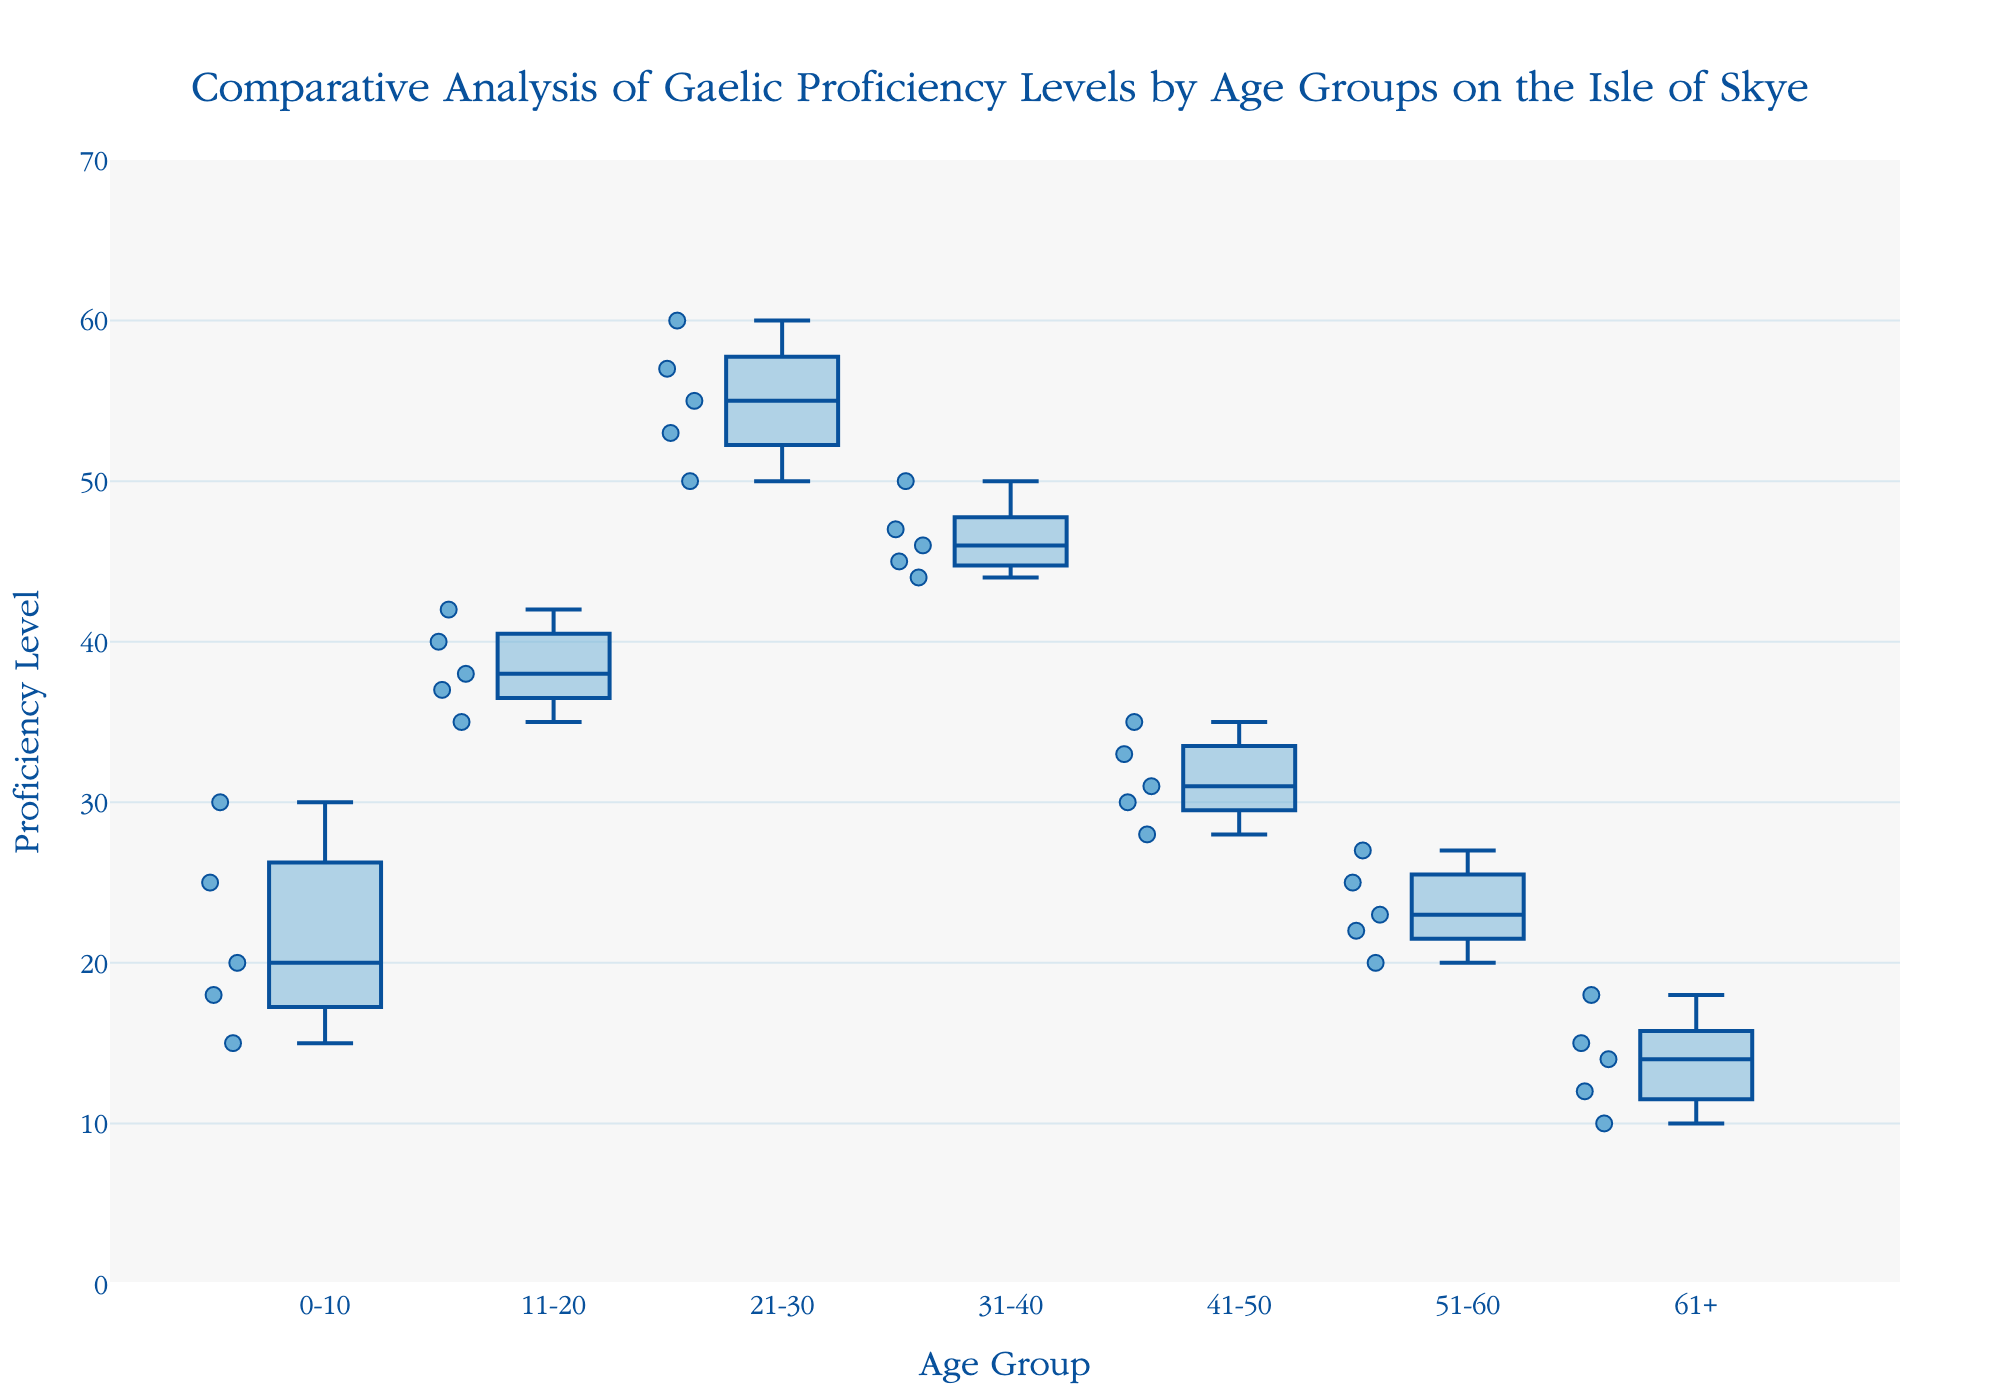what is the title of the plot? The title is positioned at the top, written in a larger font and reads "Comparative Analysis of Gaelic Proficiency Levels by Age Groups on the Isle of Skye".
Answer: Comparative Analysis of Gaelic Proficiency Levels by Age Groups on the Isle of Skye what's the range of proficiency levels on the y-axis? The y-axis is labelled "Proficiency Level" and the data points and ticks range from 0 to 70.
Answer: 0 to 70 which age group has the highest median proficiency level? By looking at the line inside each box plot which represents the median, the 21-30 age group has the highest median proficiency level.
Answer: 21-30 how many data points are there in the 0-10 age group? In the 0-10 age group, adding the scatter points within the box plot shows there are 5 data points.
Answer: 5 which age group has the widest interquartile range (IQR)? The interquartile range (IQR) is the box's height in the box plot, representing the range between the first and third quartile. The 21-30 age group has the widest box, indicating the widest IQR.
Answer: 21-30 what is the maximum proficiency level in the 41-50 age group? The maximum value in a box plot is the point at the top of the whisker or the highest outlier point for the 41-50 age group. It is 35.
Answer: 35 how do the proficiency levels of the 61+ age group compare with the proficiency levels of the 0-10 age group? Comparing the two box plots, the proficiency levels in the 61+ age group are generally lower than those in the 0-10 age group. The highest level in 61+ is 18, whereas in 0-10 it reaches up to 30.
Answer: lower what conclusion can be drawn about the proficiency levels among the different age groups? Observing all the plots, younger age groups (0-10, 11-20, 21-30) tend to have higher and more varied proficiency levels, whereas older age groups (51-60, 61+) have lower and less varied proficiency levels. This suggests that younger individuals on the Isle of Skye may have better Gaelic proficiency.
Answer: Younger groups have higher proficiency levels which age groups have data points that go beyond the interquartile range (IQR)? This can be inferred from the presence of dots outside the box (IQR) range. The 0-10, 51-60, and 61+ age groups have points beyond the IQR, indicating outliers in these age groups.
Answer: 0-10, 51-60, and 61+ what's the average proficiency level for the 31-40 age group? The sum of the proficiency levels for the 31-40 age group is (45 + 50 + 47 + 44 + 46) = 232. The number of data points is 5. Therefore, the average is 232 / 5 = 46.4
Answer: 46.4 